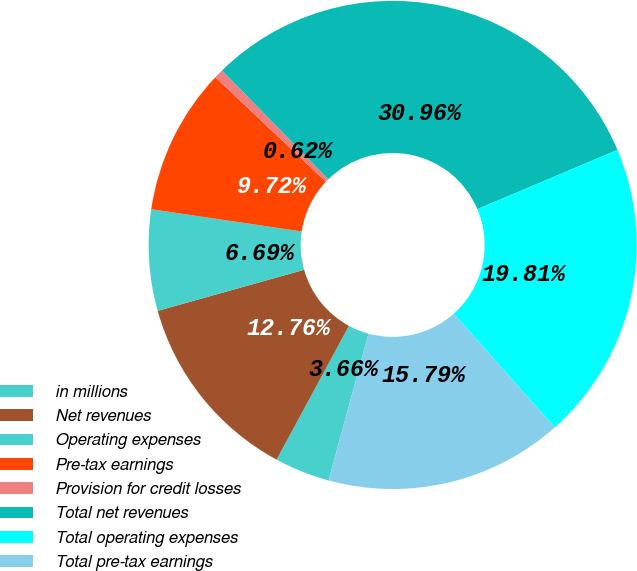Convert chart to OTSL. <chart><loc_0><loc_0><loc_500><loc_500><pie_chart><fcel>in millions<fcel>Net revenues<fcel>Operating expenses<fcel>Pre-tax earnings<fcel>Provision for credit losses<fcel>Total net revenues<fcel>Total operating expenses<fcel>Total pre-tax earnings<nl><fcel>3.66%<fcel>12.76%<fcel>6.69%<fcel>9.72%<fcel>0.62%<fcel>30.96%<fcel>19.81%<fcel>15.79%<nl></chart> 